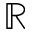<formula> <loc_0><loc_0><loc_500><loc_500>\mathbb { R }</formula> 